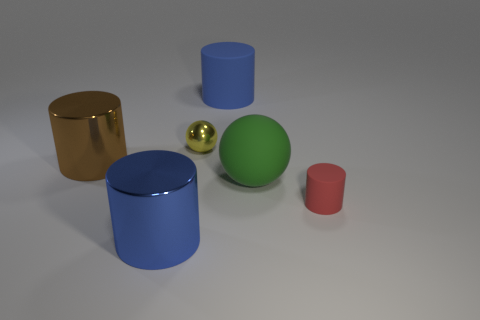There is a blue object that is behind the big brown shiny cylinder; how many blue metal cylinders are behind it?
Provide a short and direct response. 0. How many small red cylinders are left of the large matte ball?
Offer a very short reply. 0. What number of other things are the same size as the red thing?
Give a very brief answer. 1. What is the size of the other blue object that is the same shape as the large blue rubber object?
Provide a succinct answer. Large. What is the shape of the large object that is behind the small yellow shiny sphere?
Provide a succinct answer. Cylinder. There is a sphere to the right of the matte cylinder that is left of the red rubber object; what is its color?
Offer a very short reply. Green. What number of things are matte cylinders in front of the rubber ball or big blue matte cylinders?
Provide a succinct answer. 2. There is a rubber sphere; is its size the same as the blue cylinder behind the green rubber object?
Give a very brief answer. Yes. What number of tiny objects are either red rubber cylinders or spheres?
Make the answer very short. 2. What is the shape of the yellow metallic object?
Keep it short and to the point. Sphere. 